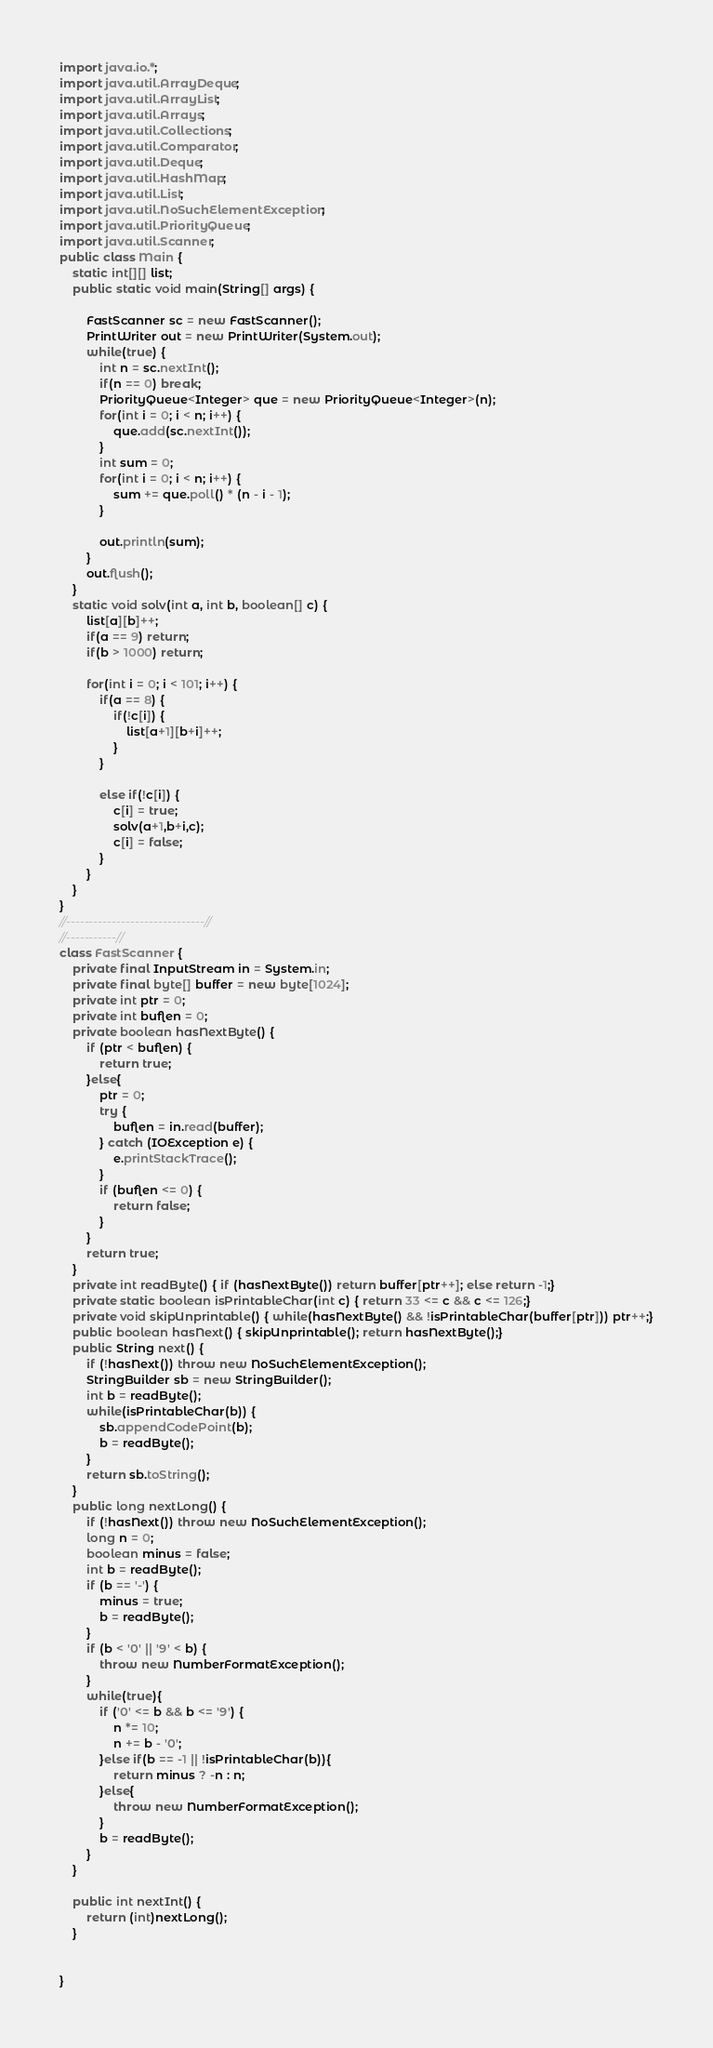<code> <loc_0><loc_0><loc_500><loc_500><_Java_>
import java.io.*;
import java.util.ArrayDeque;
import java.util.ArrayList;
import java.util.Arrays;
import java.util.Collections;
import java.util.Comparator;
import java.util.Deque;
import java.util.HashMap;
import java.util.List;
import java.util.NoSuchElementException;
import java.util.PriorityQueue;
import java.util.Scanner;
public class Main {
	static int[][] list;
	public static void main(String[] args) {
		
		FastScanner sc = new FastScanner();
		PrintWriter out = new PrintWriter(System.out);
		while(true) {
			int n = sc.nextInt();
			if(n == 0) break;
			PriorityQueue<Integer> que = new PriorityQueue<Integer>(n);
			for(int i = 0; i < n; i++) {
				que.add(sc.nextInt());
			}
			int sum = 0;
			for(int i = 0; i < n; i++) {
				sum += que.poll() * (n - i - 1);
			}
			
			out.println(sum);
		}
		out.flush();
	}
	static void solv(int a, int b, boolean[] c) {
		list[a][b]++;
		if(a == 9) return;
		if(b > 1000) return;
		
		for(int i = 0; i < 101; i++) {
			if(a == 8) {
				if(!c[i]) {
					list[a+1][b+i]++;
				}
			}
			
			else if(!c[i]) {
				c[i] = true;
				solv(a+1,b+i,c);
				c[i] = false;
			}
		}
	}
}
//------------------------------//
//-----------//
class FastScanner {
    private final InputStream in = System.in;
    private final byte[] buffer = new byte[1024];
    private int ptr = 0;
    private int buflen = 0;
    private boolean hasNextByte() {
        if (ptr < buflen) {
            return true;
        }else{
            ptr = 0;
            try {
                buflen = in.read(buffer);
            } catch (IOException e) {
                e.printStackTrace();
            }
            if (buflen <= 0) {
                return false;
            }
        }
        return true;
    }
    private int readByte() { if (hasNextByte()) return buffer[ptr++]; else return -1;}
    private static boolean isPrintableChar(int c) { return 33 <= c && c <= 126;}
    private void skipUnprintable() { while(hasNextByte() && !isPrintableChar(buffer[ptr])) ptr++;}
    public boolean hasNext() { skipUnprintable(); return hasNextByte();}
    public String next() {
        if (!hasNext()) throw new NoSuchElementException();
        StringBuilder sb = new StringBuilder();
        int b = readByte();
        while(isPrintableChar(b)) {
            sb.appendCodePoint(b);
            b = readByte();
        }
        return sb.toString();
    }
    public long nextLong() {
        if (!hasNext()) throw new NoSuchElementException();
        long n = 0;
        boolean minus = false;
        int b = readByte();
        if (b == '-') {
            minus = true;
            b = readByte();
        }
        if (b < '0' || '9' < b) {
            throw new NumberFormatException();
        }
        while(true){
            if ('0' <= b && b <= '9') {
                n *= 10;
                n += b - '0';
            }else if(b == -1 || !isPrintableChar(b)){
                return minus ? -n : n;
            }else{
                throw new NumberFormatException();
            }
            b = readByte();
        }
    }
    
    public int nextInt() {
    	return (int)nextLong();
    }
    

}</code> 